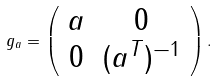Convert formula to latex. <formula><loc_0><loc_0><loc_500><loc_500>g _ { a } = \left ( \begin{array} { c c } a & 0 \\ 0 & ( a ^ { T } ) ^ { - 1 } \\ \end{array} \right ) .</formula> 